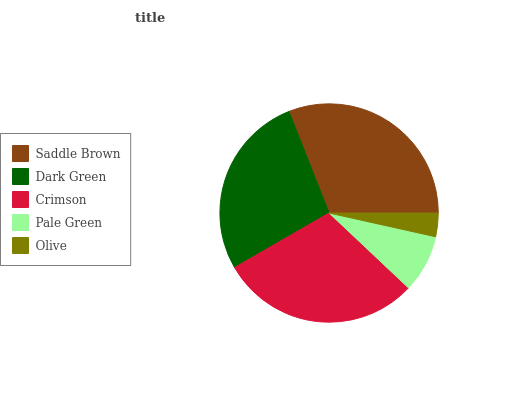Is Olive the minimum?
Answer yes or no. Yes. Is Saddle Brown the maximum?
Answer yes or no. Yes. Is Dark Green the minimum?
Answer yes or no. No. Is Dark Green the maximum?
Answer yes or no. No. Is Saddle Brown greater than Dark Green?
Answer yes or no. Yes. Is Dark Green less than Saddle Brown?
Answer yes or no. Yes. Is Dark Green greater than Saddle Brown?
Answer yes or no. No. Is Saddle Brown less than Dark Green?
Answer yes or no. No. Is Dark Green the high median?
Answer yes or no. Yes. Is Dark Green the low median?
Answer yes or no. Yes. Is Olive the high median?
Answer yes or no. No. Is Pale Green the low median?
Answer yes or no. No. 